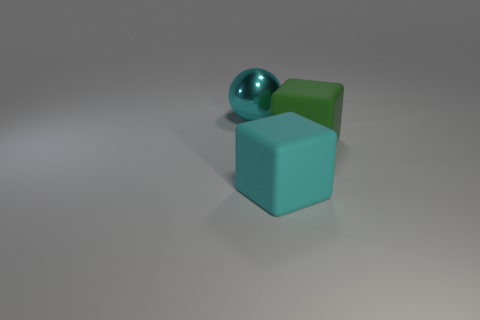How do the objects in the image relate to each other in terms of geometry? The objects in the image showcase fundamental geometric shapes in three dimensions: a sphere, a cube, and another cube-like shape with a slightly different form. The relationship lies in the contrast of their geometrical properties. The sphere has no edges or vertices, the cube has sharp edges and flat faces, and the second cube-like object appears to have rounded edges, combining attributes of both the sphere and cube. 